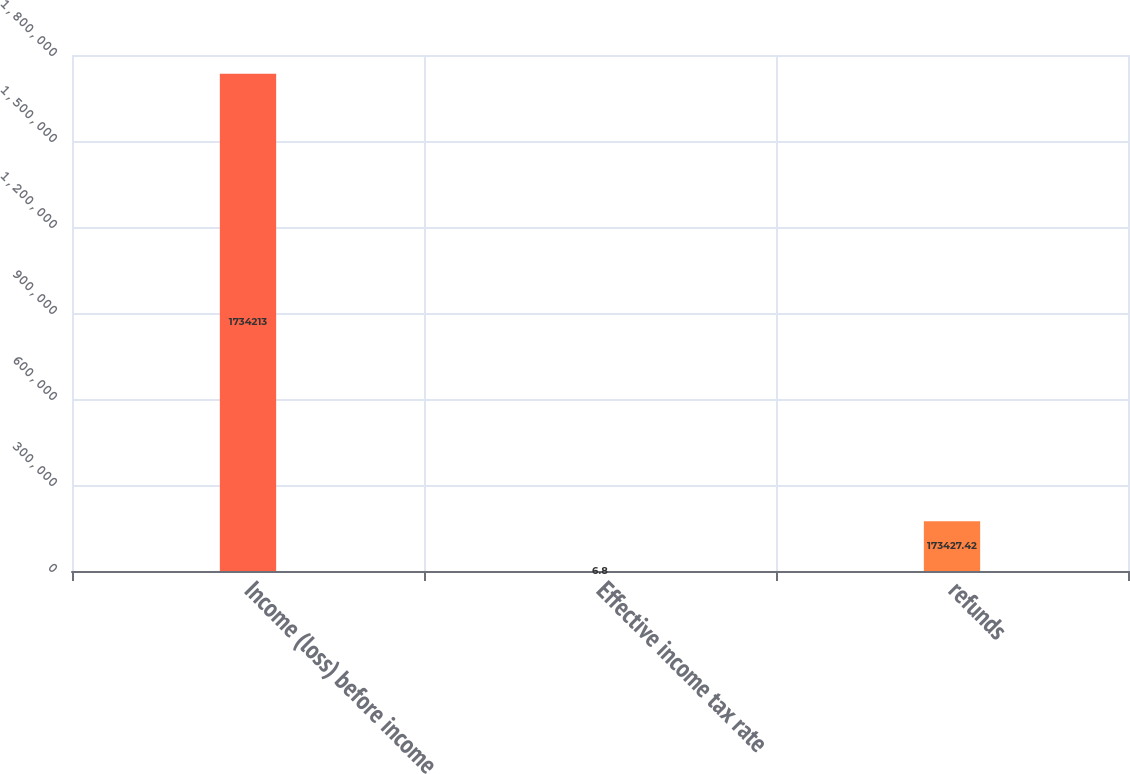<chart> <loc_0><loc_0><loc_500><loc_500><bar_chart><fcel>Income (loss) before income<fcel>Effective income tax rate<fcel>refunds<nl><fcel>1.73421e+06<fcel>6.8<fcel>173427<nl></chart> 